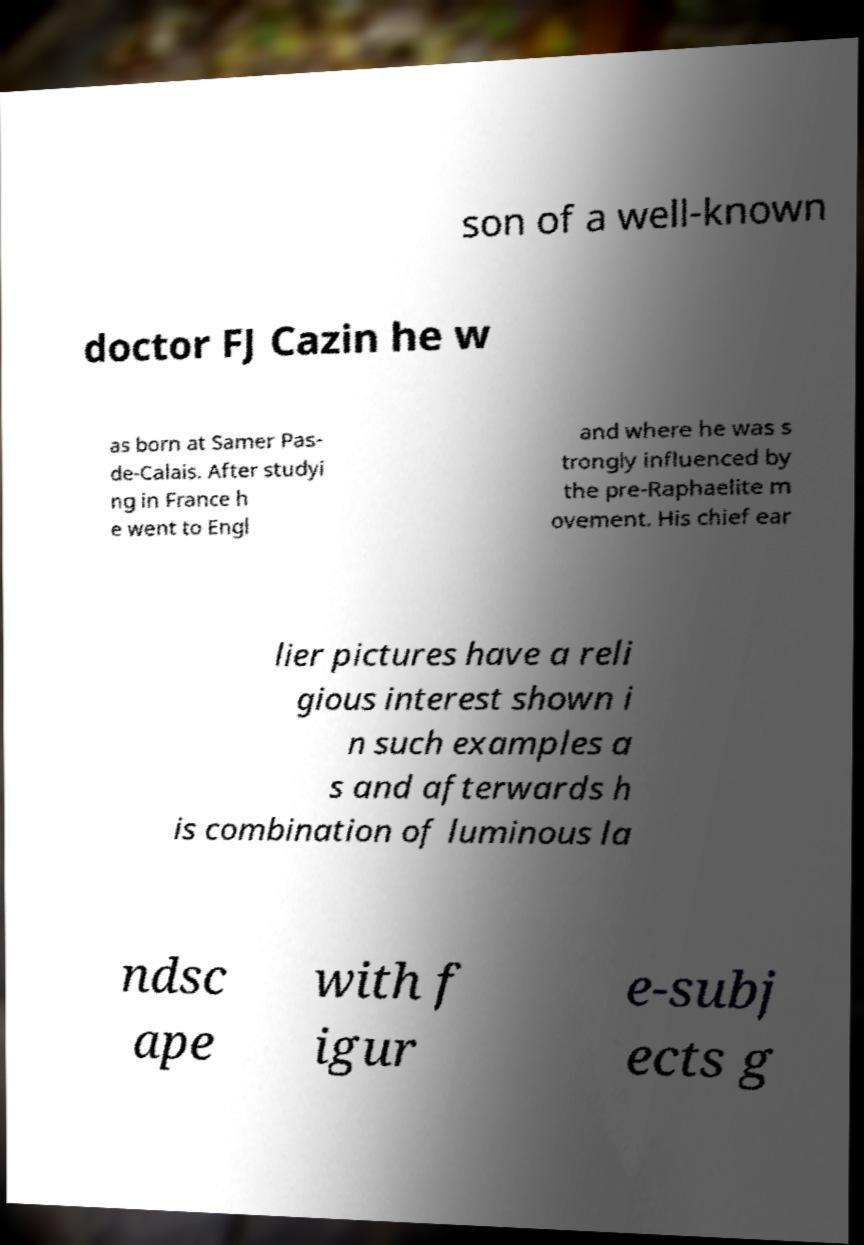Could you assist in decoding the text presented in this image and type it out clearly? son of a well-known doctor FJ Cazin he w as born at Samer Pas- de-Calais. After studyi ng in France h e went to Engl and where he was s trongly influenced by the pre-Raphaelite m ovement. His chief ear lier pictures have a reli gious interest shown i n such examples a s and afterwards h is combination of luminous la ndsc ape with f igur e-subj ects g 